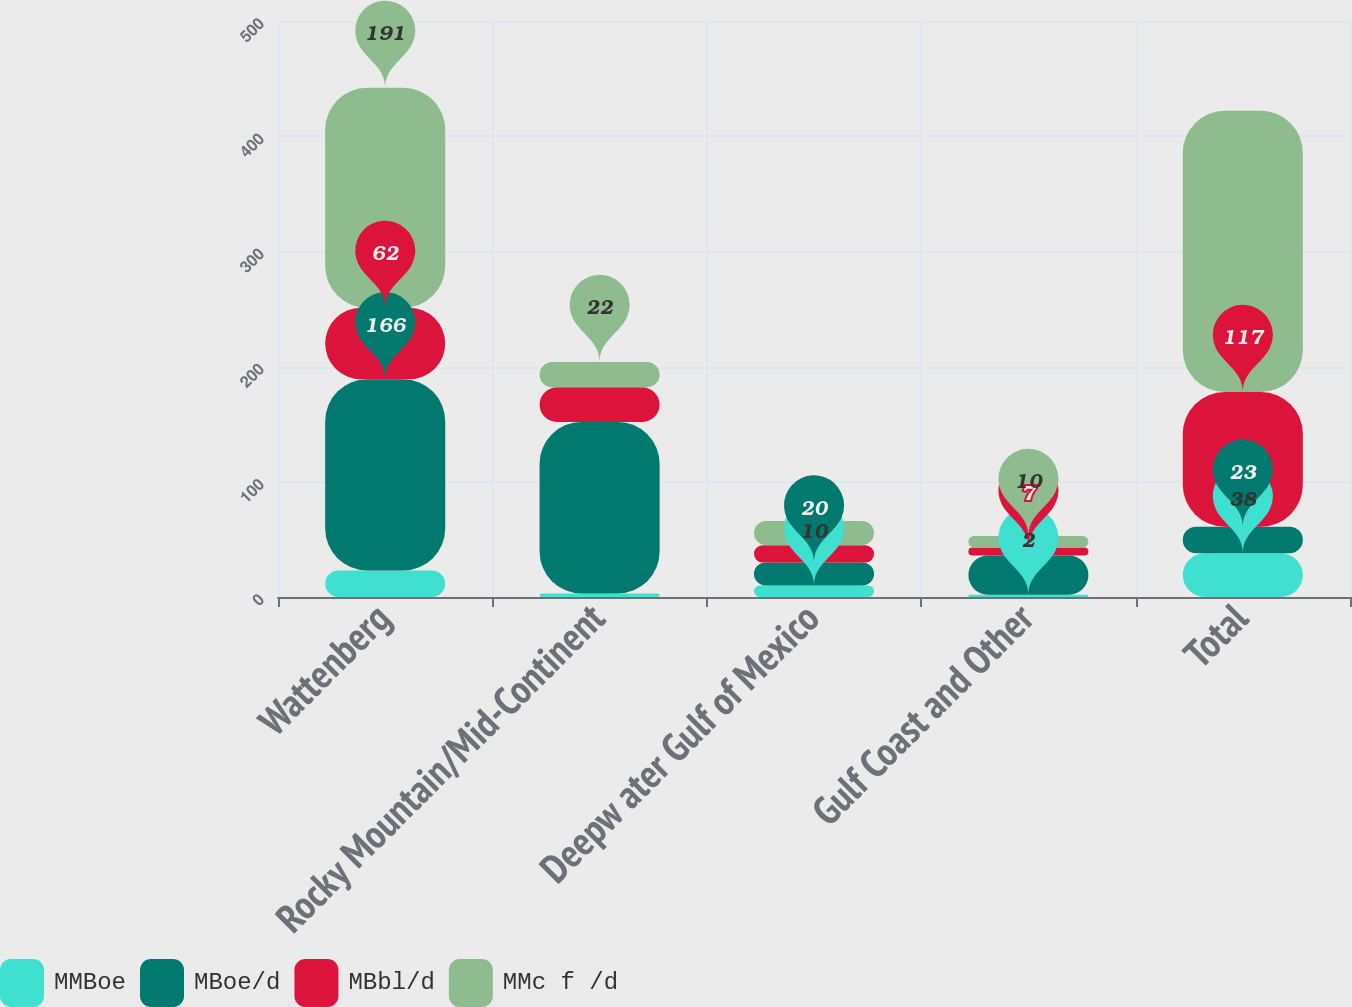<chart> <loc_0><loc_0><loc_500><loc_500><stacked_bar_chart><ecel><fcel>Wattenberg<fcel>Rocky Mountain/Mid-Continent<fcel>Deepw ater Gulf of Mexico<fcel>Gulf Coast and Other<fcel>Total<nl><fcel>MMBoe<fcel>23<fcel>3<fcel>10<fcel>2<fcel>38<nl><fcel>MBoe/d<fcel>166<fcel>149<fcel>20<fcel>34<fcel>23<nl><fcel>MBbl/d<fcel>62<fcel>30<fcel>15<fcel>7<fcel>117<nl><fcel>MMc f /d<fcel>191<fcel>22<fcel>21<fcel>10<fcel>244<nl></chart> 